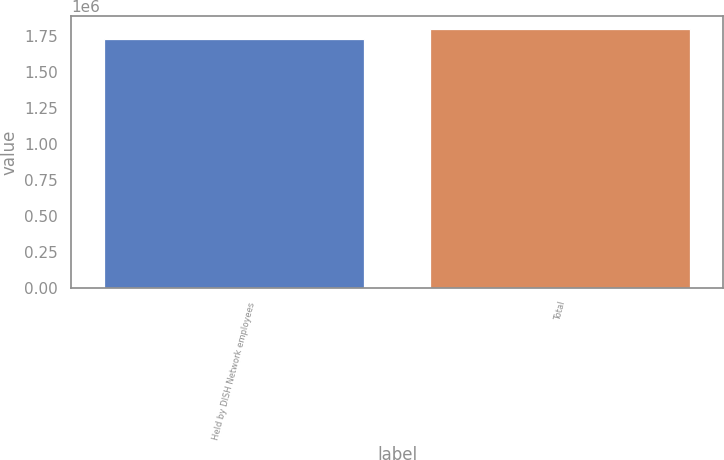Convert chart. <chart><loc_0><loc_0><loc_500><loc_500><bar_chart><fcel>Held by DISH Network employees<fcel>Total<nl><fcel>1.73133e+06<fcel>1.79833e+06<nl></chart> 